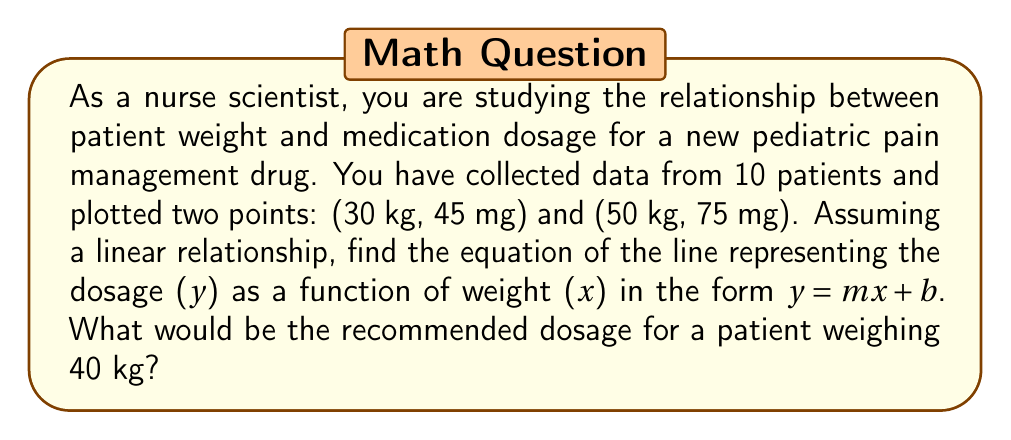Solve this math problem. To find the equation of the line, we need to follow these steps:

1. Calculate the slope (m) using the two given points:
   $m = \frac{y_2 - y_1}{x_2 - x_1} = \frac{75 - 45}{50 - 30} = \frac{30}{20} = 1.5$

2. Use the point-slope form of a line: $y - y_1 = m(x - x_1)$
   Let's use the point (30, 45):
   $y - 45 = 1.5(x - 30)$

3. Expand the equation:
   $y - 45 = 1.5x - 45$

4. Solve for y to get the slope-intercept form:
   $y = 1.5x - 45 + 45$
   $y = 1.5x$

So, the equation of the line is $y = 1.5x$

To find the recommended dosage for a patient weighing 40 kg:
Substitute x = 40 into the equation:
$y = 1.5(40) = 60$

Therefore, the recommended dosage for a 40 kg patient would be 60 mg.
Answer: The equation of the line is $y = 1.5x$, and the recommended dosage for a patient weighing 40 kg is 60 mg. 